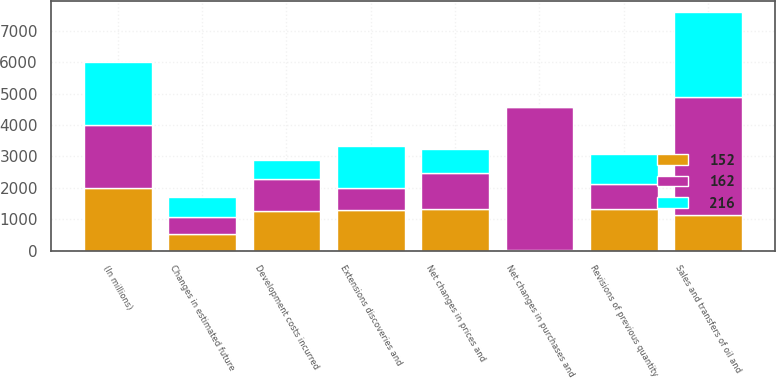Convert chart to OTSL. <chart><loc_0><loc_0><loc_500><loc_500><stacked_bar_chart><ecel><fcel>(In millions)<fcel>Sales and transfers of oil and<fcel>Net changes in prices and<fcel>Extensions discoveries and<fcel>Development costs incurred<fcel>Changes in estimated future<fcel>Revisions of previous quantity<fcel>Net changes in purchases and<nl><fcel>152<fcel>2006<fcel>1140.5<fcel>1342<fcel>1290<fcel>1251<fcel>527<fcel>1319<fcel>30<nl><fcel>162<fcel>2005<fcel>3754<fcel>1140.5<fcel>700<fcel>1030<fcel>552<fcel>820<fcel>4557<nl><fcel>216<fcel>2004<fcel>2689<fcel>771<fcel>1349<fcel>609<fcel>628<fcel>948<fcel>33<nl></chart> 